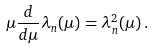<formula> <loc_0><loc_0><loc_500><loc_500>\mu \frac { d } { d \mu } \lambda _ { n } ( \mu ) = \lambda _ { n } ^ { 2 } ( \mu ) \, .</formula> 